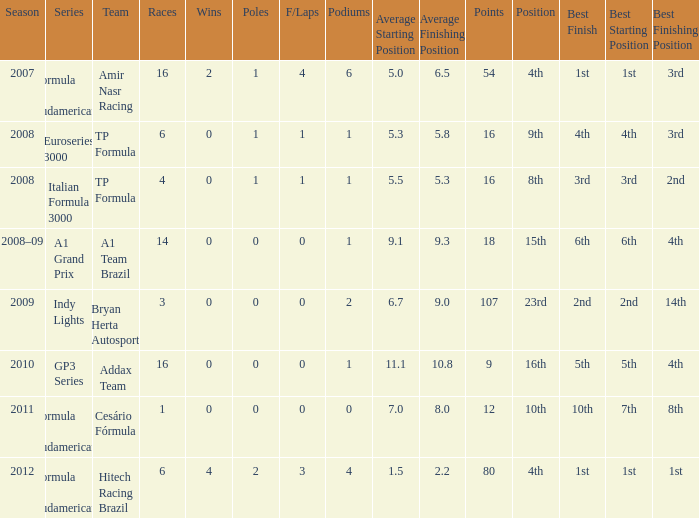How many points were awarded to him for the race in which he had more than 1.0 poles? 80.0. 